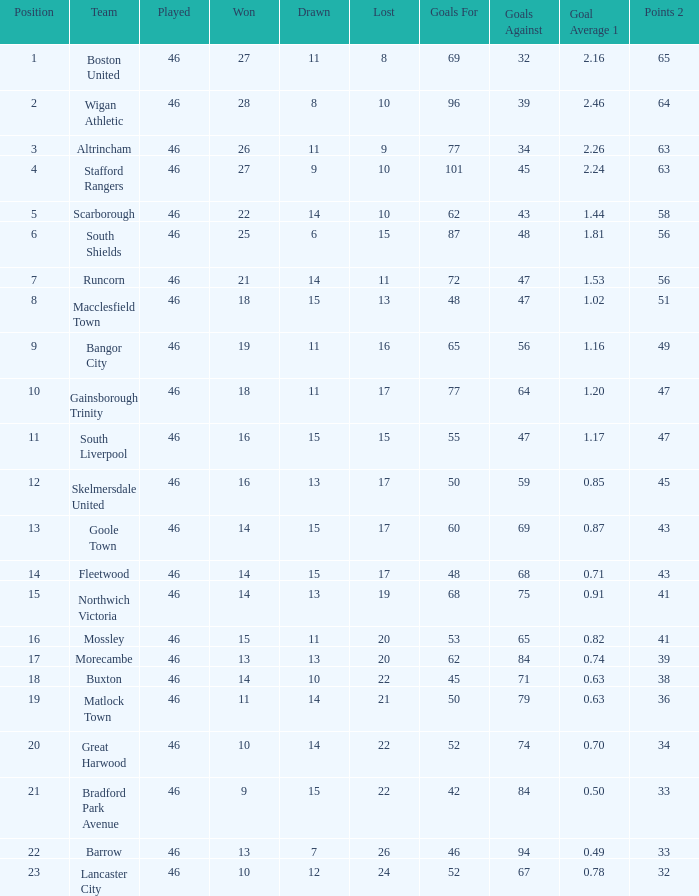How many points did goole town amass? 1.0. 